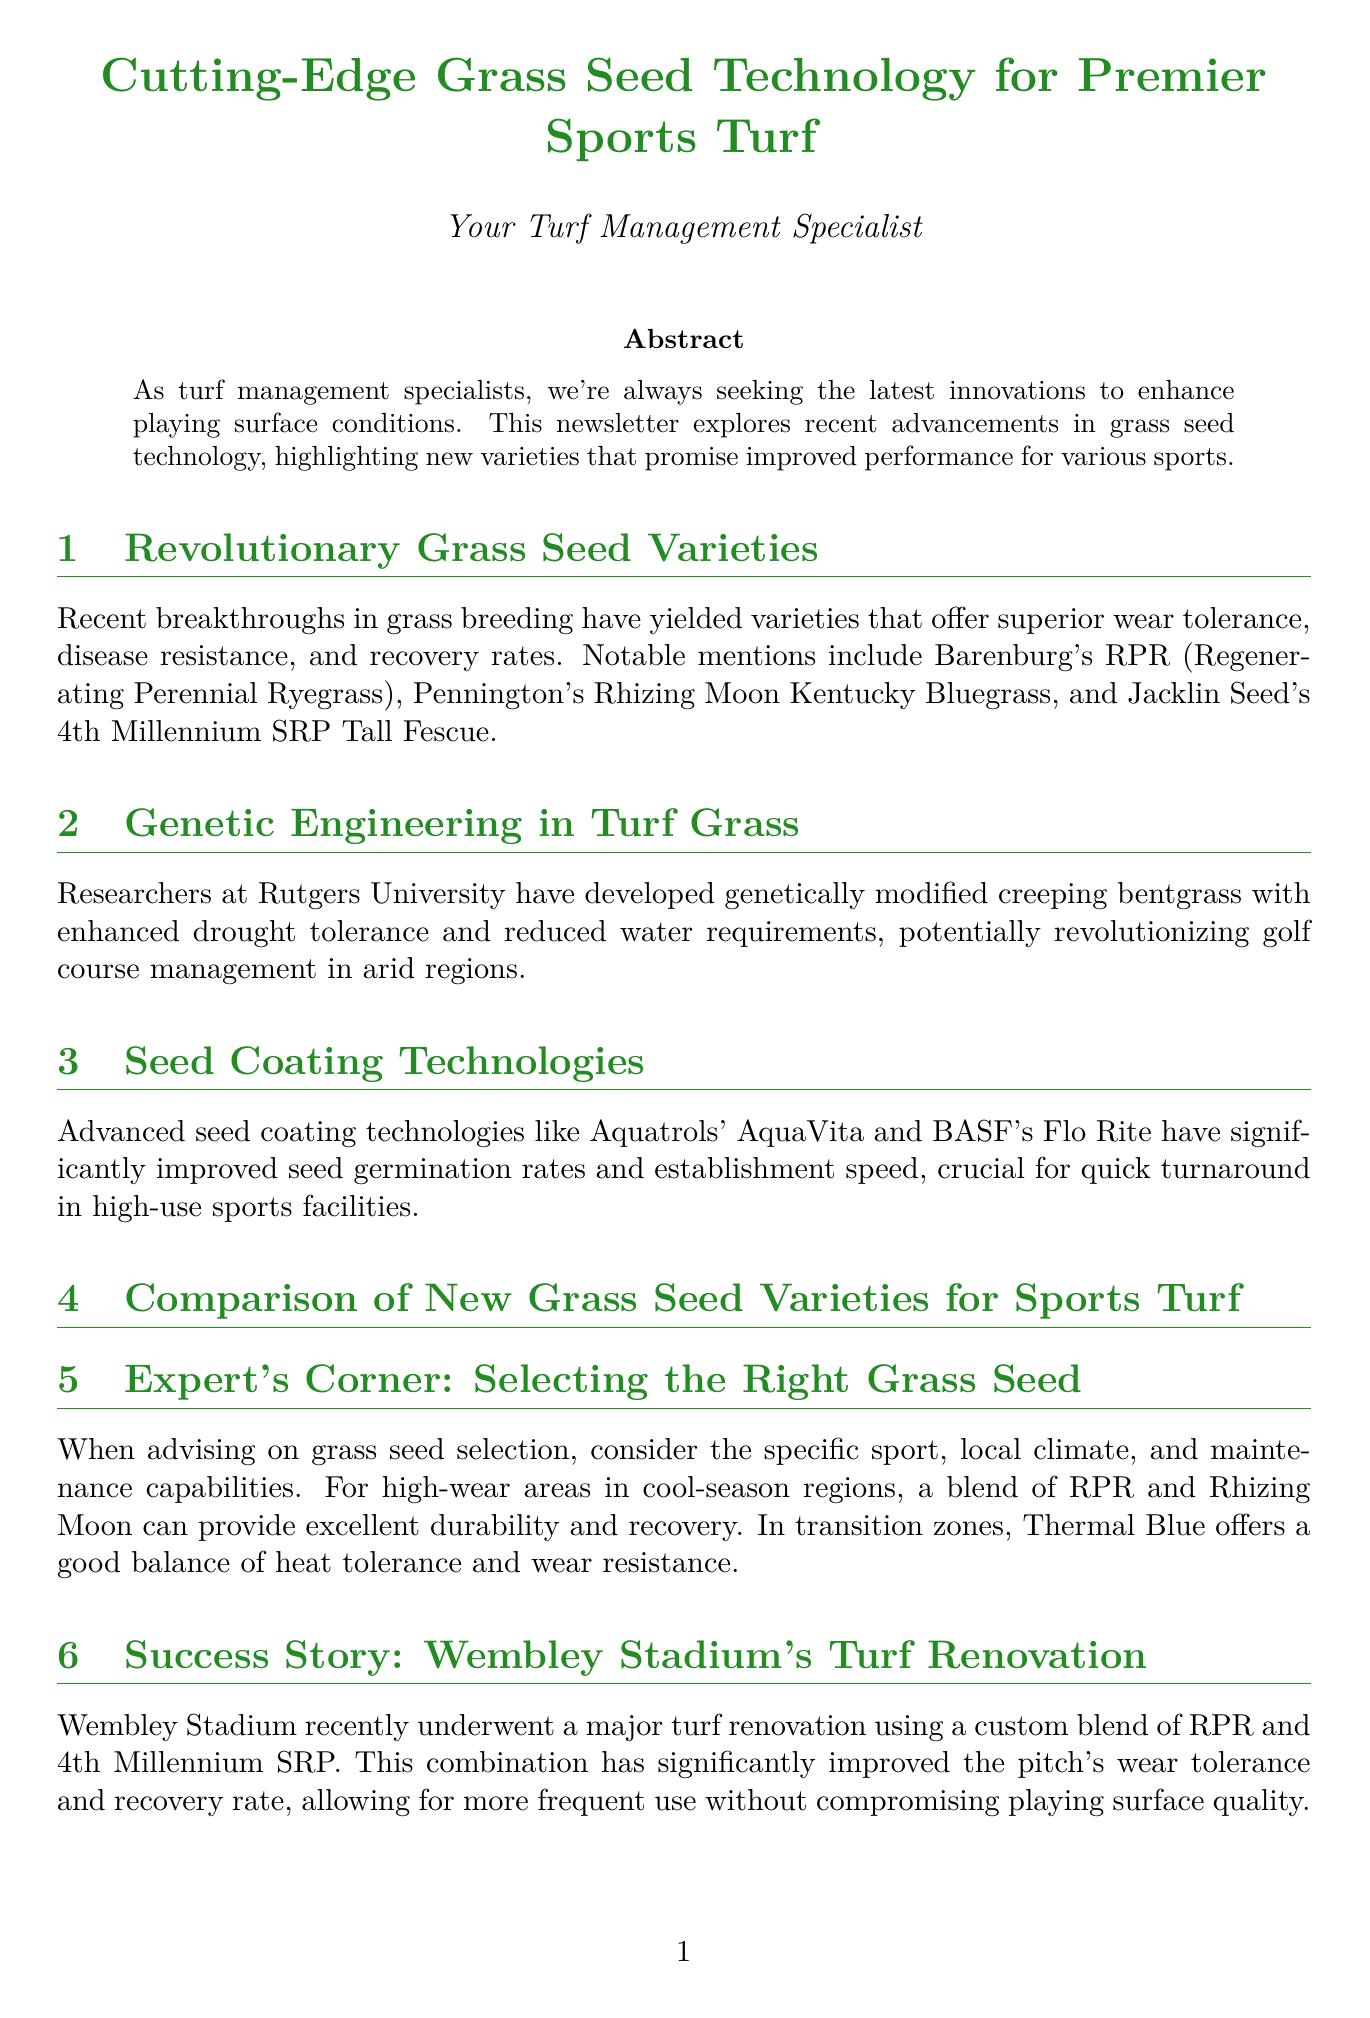What is the newsletter title? The newsletter title is specified in the document's title section.
Answer: Cutting-Edge Grass Seed Technology for Premier Sports Turf Who developed the genetically modified creeping bentgrass? The document mentions researchers at Rutgers University as the developers of the genetically modified creeping bentgrass.
Answer: Rutgers University Which grass seed variety is recommended for Soccer and Rugby? The ideal sports applications for each variety are listed in the comparison chart.
Answer: RPR (Barenburg) What is the wear tolerance level of Rhizing Moon Kentucky Bluegrass? The wear tolerance level is included in the comparison chart for Rhizing Moon Kentucky Bluegrass.
Answer: Very Good What coating technology is mentioned for improving seed germination rates? The document cites specific seed coating technologies that improve germination rates.
Answer: AquaVita In which location did a turf renovation that improved wear tolerance recently occur? The document provides a case study about a turf renovation at a well-known location.
Answer: Wembley Stadium What is the recovery rate of 4th Millennium SRP Tall Fescue? The recovery rates for each grass seed variety are listed in the comparison chart.
Answer: Moderate Which grass seed variety has excellent drought tolerance? The document lists drought tolerance for each variety in the comparison chart.
Answer: 4th Millennium SRP (Jacklin Seed) What is emphasized in the Expert's Corner section? The Expert's Corner provides insights on selecting the right grass seed, considering specific factors.
Answer: Specific sport, local climate, and maintenance capabilities 